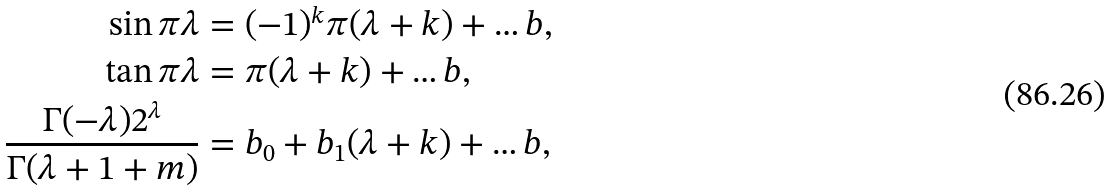Convert formula to latex. <formula><loc_0><loc_0><loc_500><loc_500>\sin \pi \lambda & = ( - 1 ) ^ { k } \pi ( \lambda + k ) + \dots b , \\ \tan \pi \lambda & = \pi ( \lambda + k ) + \dots b , \\ \frac { \Gamma ( - \lambda ) 2 ^ { \lambda } } { \Gamma ( \lambda + 1 + m ) } & = b _ { 0 } + b _ { 1 } ( \lambda + k ) + \dots b ,</formula> 